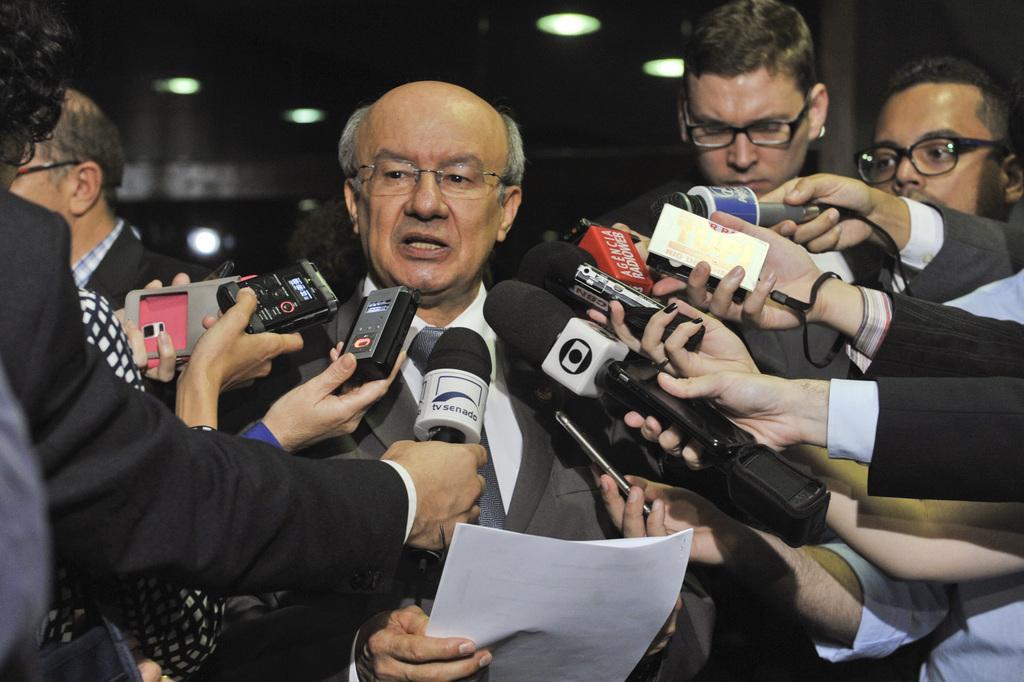Can you describe this image briefly? In this picture we can see some people are standing, a person in the middle is holding papers, the persons in the front are holding microphones, in the background there are some lights. 